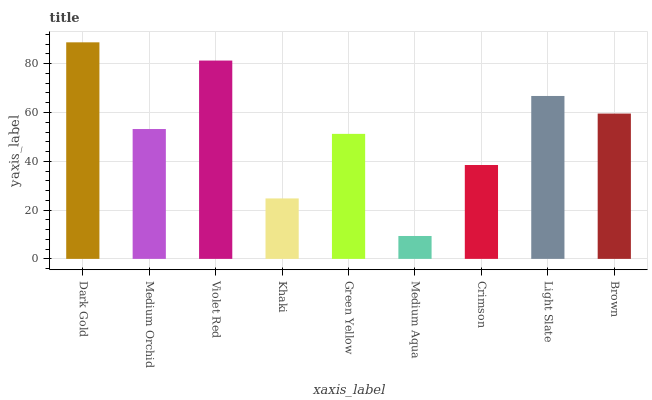Is Medium Aqua the minimum?
Answer yes or no. Yes. Is Dark Gold the maximum?
Answer yes or no. Yes. Is Medium Orchid the minimum?
Answer yes or no. No. Is Medium Orchid the maximum?
Answer yes or no. No. Is Dark Gold greater than Medium Orchid?
Answer yes or no. Yes. Is Medium Orchid less than Dark Gold?
Answer yes or no. Yes. Is Medium Orchid greater than Dark Gold?
Answer yes or no. No. Is Dark Gold less than Medium Orchid?
Answer yes or no. No. Is Medium Orchid the high median?
Answer yes or no. Yes. Is Medium Orchid the low median?
Answer yes or no. Yes. Is Light Slate the high median?
Answer yes or no. No. Is Light Slate the low median?
Answer yes or no. No. 